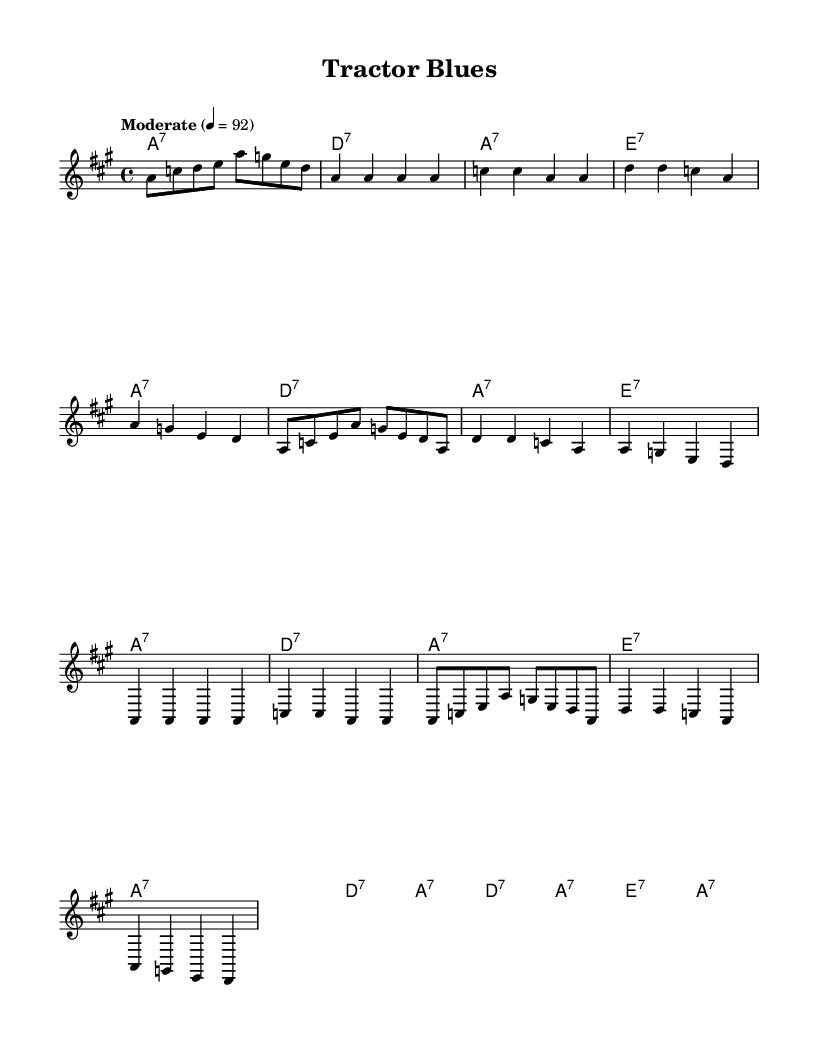What is the key signature of this music? The key signature is A major, indicated by three sharps (F#, C#, and G#) shown at the beginning of the staff.
Answer: A major What is the time signature of this piece? The time signature is 4/4, indicated by the notation at the beginning of the music. It means there are four beats in each measure, with a quarter note receiving one beat.
Answer: 4/4 What is the tempo marking for the piece? The tempo marking is "Moderate," indicated in the score before the actual notes start, along with a metronome marking of 92 beats per minute.
Answer: Moderate How many measures are in the first chorus? The first chorus consists of four measures, which can be counted as each group of notes separated by vertical bar lines.
Answer: 4 What type of chords are used throughout the piece? The chords used are seventh chords, as indicated by the notation (e.g., A:7, D:7, E:7) in the chord section of the score.
Answer: Seventh chords What is the structure of the song based on the verses and chorus? The structure alternates between verses and a repeated chorus, specifically following a pattern of Verse 1, Chorus, Verse 2, and Chorus again. This repetition is typical in Blues music.
Answer: Verse-Chorus pattern How does the melody in the first verse begin? The melody in the first verse begins with the note 'A' followed by repeated 'A' notes, as seen in the first few measures of the verse indicated in the melody line.
Answer: Starts with 'A' 